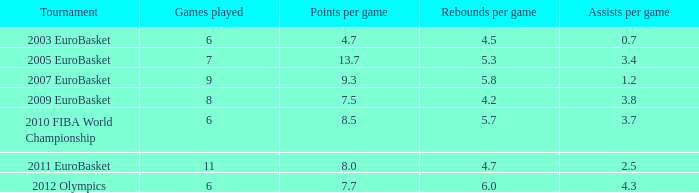7 points per game? 1.0. 